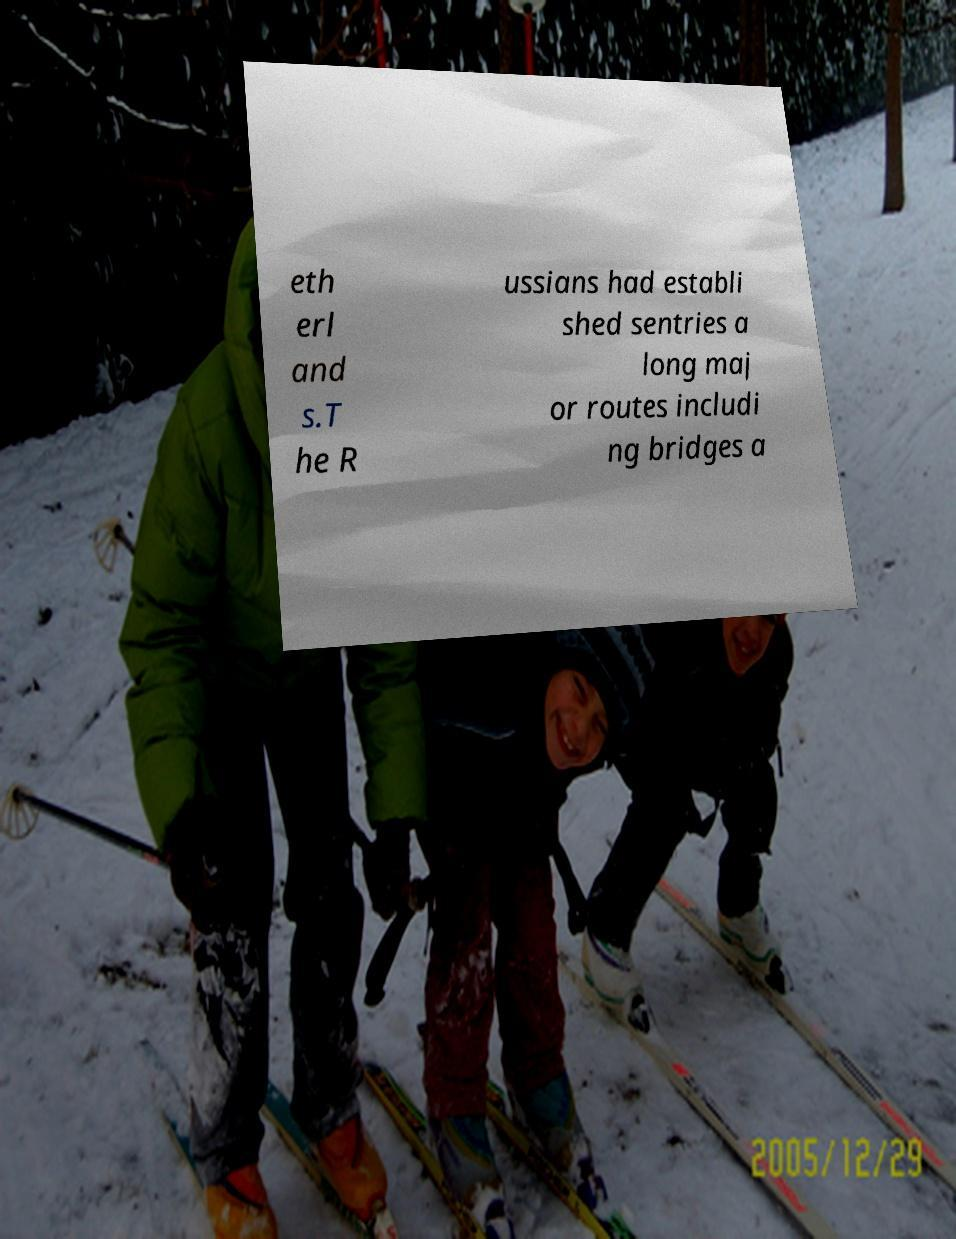Please read and relay the text visible in this image. What does it say? eth erl and s.T he R ussians had establi shed sentries a long maj or routes includi ng bridges a 